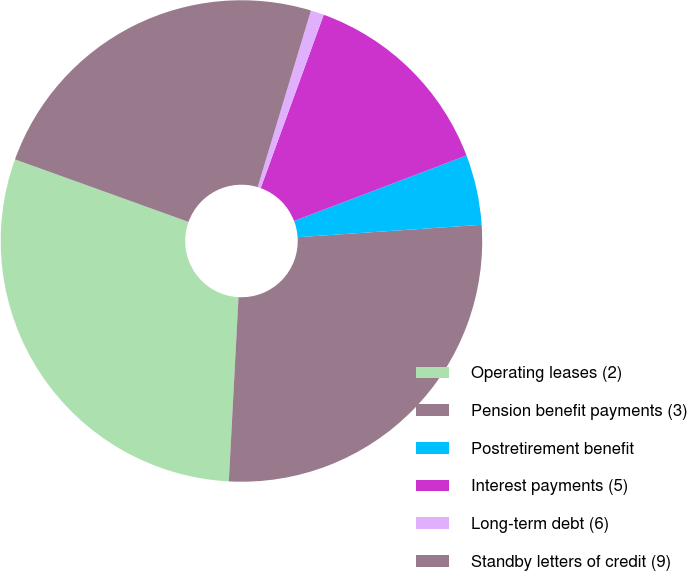Convert chart. <chart><loc_0><loc_0><loc_500><loc_500><pie_chart><fcel>Operating leases (2)<fcel>Pension benefit payments (3)<fcel>Postretirement benefit<fcel>Interest payments (5)<fcel>Long-term debt (6)<fcel>Standby letters of credit (9)<nl><fcel>29.67%<fcel>26.91%<fcel>4.71%<fcel>13.67%<fcel>0.89%<fcel>24.16%<nl></chart> 